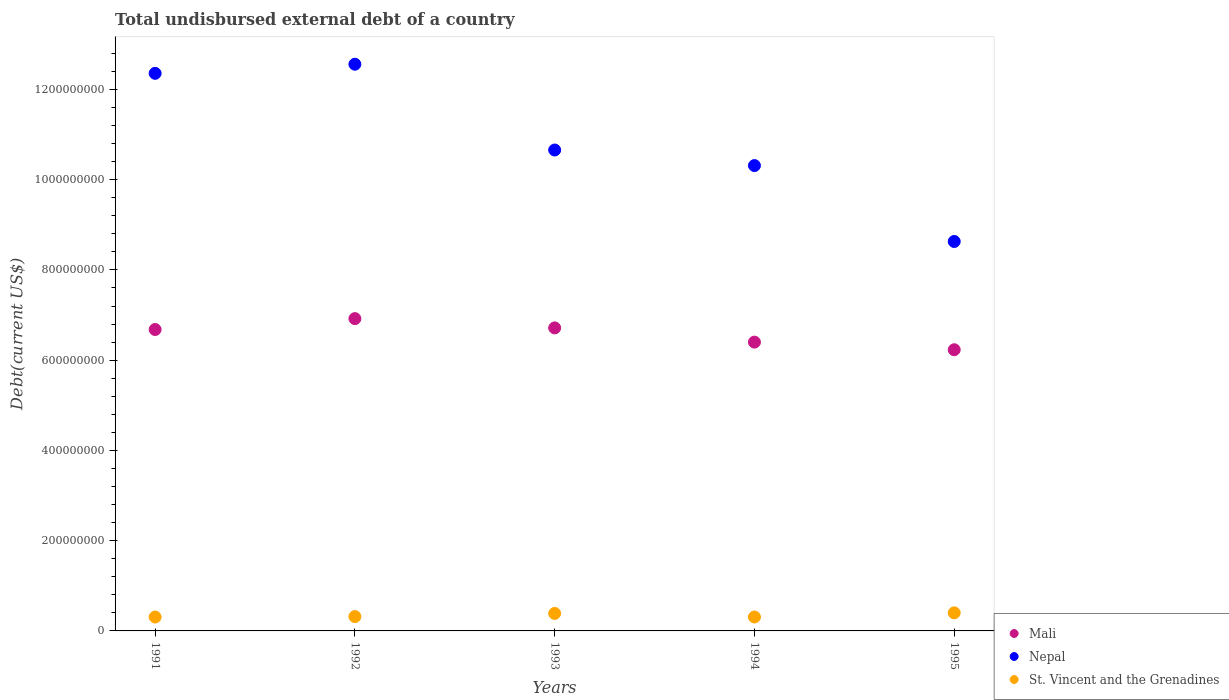What is the total undisbursed external debt in St. Vincent and the Grenadines in 1994?
Offer a terse response. 3.09e+07. Across all years, what is the maximum total undisbursed external debt in St. Vincent and the Grenadines?
Keep it short and to the point. 4.00e+07. Across all years, what is the minimum total undisbursed external debt in Nepal?
Your response must be concise. 8.63e+08. In which year was the total undisbursed external debt in Mali minimum?
Give a very brief answer. 1995. What is the total total undisbursed external debt in St. Vincent and the Grenadines in the graph?
Give a very brief answer. 1.72e+08. What is the difference between the total undisbursed external debt in St. Vincent and the Grenadines in 1992 and that in 1994?
Your answer should be compact. 9.48e+05. What is the difference between the total undisbursed external debt in St. Vincent and the Grenadines in 1993 and the total undisbursed external debt in Mali in 1994?
Make the answer very short. -6.01e+08. What is the average total undisbursed external debt in St. Vincent and the Grenadines per year?
Ensure brevity in your answer.  3.45e+07. In the year 1992, what is the difference between the total undisbursed external debt in St. Vincent and the Grenadines and total undisbursed external debt in Mali?
Offer a terse response. -6.60e+08. What is the ratio of the total undisbursed external debt in Mali in 1994 to that in 1995?
Give a very brief answer. 1.03. What is the difference between the highest and the second highest total undisbursed external debt in Nepal?
Your answer should be very brief. 2.02e+07. What is the difference between the highest and the lowest total undisbursed external debt in St. Vincent and the Grenadines?
Your response must be concise. 9.23e+06. In how many years, is the total undisbursed external debt in Nepal greater than the average total undisbursed external debt in Nepal taken over all years?
Keep it short and to the point. 2. Is the sum of the total undisbursed external debt in Mali in 1993 and 1995 greater than the maximum total undisbursed external debt in St. Vincent and the Grenadines across all years?
Your answer should be very brief. Yes. Does the total undisbursed external debt in St. Vincent and the Grenadines monotonically increase over the years?
Your answer should be very brief. No. Is the total undisbursed external debt in Mali strictly less than the total undisbursed external debt in St. Vincent and the Grenadines over the years?
Offer a terse response. No. How many dotlines are there?
Your response must be concise. 3. How many years are there in the graph?
Ensure brevity in your answer.  5. What is the difference between two consecutive major ticks on the Y-axis?
Make the answer very short. 2.00e+08. Are the values on the major ticks of Y-axis written in scientific E-notation?
Keep it short and to the point. No. Does the graph contain any zero values?
Your answer should be compact. No. Where does the legend appear in the graph?
Your answer should be compact. Bottom right. How are the legend labels stacked?
Provide a short and direct response. Vertical. What is the title of the graph?
Ensure brevity in your answer.  Total undisbursed external debt of a country. What is the label or title of the X-axis?
Give a very brief answer. Years. What is the label or title of the Y-axis?
Make the answer very short. Debt(current US$). What is the Debt(current US$) in Mali in 1991?
Make the answer very short. 6.68e+08. What is the Debt(current US$) in Nepal in 1991?
Your answer should be compact. 1.24e+09. What is the Debt(current US$) of St. Vincent and the Grenadines in 1991?
Your response must be concise. 3.08e+07. What is the Debt(current US$) of Mali in 1992?
Keep it short and to the point. 6.92e+08. What is the Debt(current US$) in Nepal in 1992?
Your answer should be very brief. 1.26e+09. What is the Debt(current US$) of St. Vincent and the Grenadines in 1992?
Your answer should be very brief. 3.18e+07. What is the Debt(current US$) in Mali in 1993?
Your response must be concise. 6.72e+08. What is the Debt(current US$) of Nepal in 1993?
Your answer should be very brief. 1.07e+09. What is the Debt(current US$) in St. Vincent and the Grenadines in 1993?
Make the answer very short. 3.88e+07. What is the Debt(current US$) of Mali in 1994?
Offer a very short reply. 6.40e+08. What is the Debt(current US$) in Nepal in 1994?
Provide a succinct answer. 1.03e+09. What is the Debt(current US$) in St. Vincent and the Grenadines in 1994?
Offer a terse response. 3.09e+07. What is the Debt(current US$) of Mali in 1995?
Your answer should be very brief. 6.23e+08. What is the Debt(current US$) in Nepal in 1995?
Keep it short and to the point. 8.63e+08. What is the Debt(current US$) of St. Vincent and the Grenadines in 1995?
Offer a very short reply. 4.00e+07. Across all years, what is the maximum Debt(current US$) in Mali?
Keep it short and to the point. 6.92e+08. Across all years, what is the maximum Debt(current US$) of Nepal?
Your response must be concise. 1.26e+09. Across all years, what is the maximum Debt(current US$) in St. Vincent and the Grenadines?
Provide a succinct answer. 4.00e+07. Across all years, what is the minimum Debt(current US$) in Mali?
Provide a short and direct response. 6.23e+08. Across all years, what is the minimum Debt(current US$) of Nepal?
Provide a short and direct response. 8.63e+08. Across all years, what is the minimum Debt(current US$) of St. Vincent and the Grenadines?
Ensure brevity in your answer.  3.08e+07. What is the total Debt(current US$) of Mali in the graph?
Keep it short and to the point. 3.29e+09. What is the total Debt(current US$) in Nepal in the graph?
Offer a terse response. 5.45e+09. What is the total Debt(current US$) of St. Vincent and the Grenadines in the graph?
Offer a very short reply. 1.72e+08. What is the difference between the Debt(current US$) in Mali in 1991 and that in 1992?
Your response must be concise. -2.41e+07. What is the difference between the Debt(current US$) in Nepal in 1991 and that in 1992?
Your answer should be very brief. -2.02e+07. What is the difference between the Debt(current US$) of St. Vincent and the Grenadines in 1991 and that in 1992?
Provide a succinct answer. -1.03e+06. What is the difference between the Debt(current US$) in Mali in 1991 and that in 1993?
Make the answer very short. -3.56e+06. What is the difference between the Debt(current US$) of Nepal in 1991 and that in 1993?
Provide a short and direct response. 1.70e+08. What is the difference between the Debt(current US$) of St. Vincent and the Grenadines in 1991 and that in 1993?
Offer a terse response. -7.96e+06. What is the difference between the Debt(current US$) in Mali in 1991 and that in 1994?
Provide a short and direct response. 2.80e+07. What is the difference between the Debt(current US$) of Nepal in 1991 and that in 1994?
Keep it short and to the point. 2.04e+08. What is the difference between the Debt(current US$) in St. Vincent and the Grenadines in 1991 and that in 1994?
Offer a terse response. -8.10e+04. What is the difference between the Debt(current US$) of Mali in 1991 and that in 1995?
Offer a terse response. 4.48e+07. What is the difference between the Debt(current US$) in Nepal in 1991 and that in 1995?
Provide a short and direct response. 3.73e+08. What is the difference between the Debt(current US$) in St. Vincent and the Grenadines in 1991 and that in 1995?
Your response must be concise. -9.23e+06. What is the difference between the Debt(current US$) of Mali in 1992 and that in 1993?
Your response must be concise. 2.06e+07. What is the difference between the Debt(current US$) in Nepal in 1992 and that in 1993?
Your answer should be very brief. 1.90e+08. What is the difference between the Debt(current US$) in St. Vincent and the Grenadines in 1992 and that in 1993?
Your answer should be very brief. -6.93e+06. What is the difference between the Debt(current US$) of Mali in 1992 and that in 1994?
Make the answer very short. 5.21e+07. What is the difference between the Debt(current US$) in Nepal in 1992 and that in 1994?
Provide a short and direct response. 2.25e+08. What is the difference between the Debt(current US$) in St. Vincent and the Grenadines in 1992 and that in 1994?
Your answer should be compact. 9.48e+05. What is the difference between the Debt(current US$) in Mali in 1992 and that in 1995?
Offer a very short reply. 6.90e+07. What is the difference between the Debt(current US$) of Nepal in 1992 and that in 1995?
Give a very brief answer. 3.93e+08. What is the difference between the Debt(current US$) in St. Vincent and the Grenadines in 1992 and that in 1995?
Provide a succinct answer. -8.20e+06. What is the difference between the Debt(current US$) in Mali in 1993 and that in 1994?
Ensure brevity in your answer.  3.15e+07. What is the difference between the Debt(current US$) in Nepal in 1993 and that in 1994?
Your response must be concise. 3.45e+07. What is the difference between the Debt(current US$) in St. Vincent and the Grenadines in 1993 and that in 1994?
Provide a succinct answer. 7.87e+06. What is the difference between the Debt(current US$) in Mali in 1993 and that in 1995?
Give a very brief answer. 4.84e+07. What is the difference between the Debt(current US$) of Nepal in 1993 and that in 1995?
Offer a terse response. 2.03e+08. What is the difference between the Debt(current US$) in St. Vincent and the Grenadines in 1993 and that in 1995?
Offer a terse response. -1.28e+06. What is the difference between the Debt(current US$) of Mali in 1994 and that in 1995?
Provide a succinct answer. 1.69e+07. What is the difference between the Debt(current US$) of Nepal in 1994 and that in 1995?
Give a very brief answer. 1.68e+08. What is the difference between the Debt(current US$) in St. Vincent and the Grenadines in 1994 and that in 1995?
Keep it short and to the point. -9.15e+06. What is the difference between the Debt(current US$) of Mali in 1991 and the Debt(current US$) of Nepal in 1992?
Give a very brief answer. -5.88e+08. What is the difference between the Debt(current US$) in Mali in 1991 and the Debt(current US$) in St. Vincent and the Grenadines in 1992?
Keep it short and to the point. 6.36e+08. What is the difference between the Debt(current US$) in Nepal in 1991 and the Debt(current US$) in St. Vincent and the Grenadines in 1992?
Give a very brief answer. 1.20e+09. What is the difference between the Debt(current US$) of Mali in 1991 and the Debt(current US$) of Nepal in 1993?
Provide a succinct answer. -3.98e+08. What is the difference between the Debt(current US$) in Mali in 1991 and the Debt(current US$) in St. Vincent and the Grenadines in 1993?
Provide a succinct answer. 6.29e+08. What is the difference between the Debt(current US$) of Nepal in 1991 and the Debt(current US$) of St. Vincent and the Grenadines in 1993?
Your response must be concise. 1.20e+09. What is the difference between the Debt(current US$) of Mali in 1991 and the Debt(current US$) of Nepal in 1994?
Your response must be concise. -3.63e+08. What is the difference between the Debt(current US$) of Mali in 1991 and the Debt(current US$) of St. Vincent and the Grenadines in 1994?
Ensure brevity in your answer.  6.37e+08. What is the difference between the Debt(current US$) of Nepal in 1991 and the Debt(current US$) of St. Vincent and the Grenadines in 1994?
Provide a short and direct response. 1.20e+09. What is the difference between the Debt(current US$) in Mali in 1991 and the Debt(current US$) in Nepal in 1995?
Provide a succinct answer. -1.95e+08. What is the difference between the Debt(current US$) in Mali in 1991 and the Debt(current US$) in St. Vincent and the Grenadines in 1995?
Provide a succinct answer. 6.28e+08. What is the difference between the Debt(current US$) of Nepal in 1991 and the Debt(current US$) of St. Vincent and the Grenadines in 1995?
Your answer should be compact. 1.20e+09. What is the difference between the Debt(current US$) in Mali in 1992 and the Debt(current US$) in Nepal in 1993?
Ensure brevity in your answer.  -3.74e+08. What is the difference between the Debt(current US$) in Mali in 1992 and the Debt(current US$) in St. Vincent and the Grenadines in 1993?
Your answer should be very brief. 6.53e+08. What is the difference between the Debt(current US$) in Nepal in 1992 and the Debt(current US$) in St. Vincent and the Grenadines in 1993?
Ensure brevity in your answer.  1.22e+09. What is the difference between the Debt(current US$) of Mali in 1992 and the Debt(current US$) of Nepal in 1994?
Your answer should be compact. -3.39e+08. What is the difference between the Debt(current US$) in Mali in 1992 and the Debt(current US$) in St. Vincent and the Grenadines in 1994?
Give a very brief answer. 6.61e+08. What is the difference between the Debt(current US$) in Nepal in 1992 and the Debt(current US$) in St. Vincent and the Grenadines in 1994?
Offer a very short reply. 1.23e+09. What is the difference between the Debt(current US$) in Mali in 1992 and the Debt(current US$) in Nepal in 1995?
Provide a short and direct response. -1.71e+08. What is the difference between the Debt(current US$) of Mali in 1992 and the Debt(current US$) of St. Vincent and the Grenadines in 1995?
Ensure brevity in your answer.  6.52e+08. What is the difference between the Debt(current US$) of Nepal in 1992 and the Debt(current US$) of St. Vincent and the Grenadines in 1995?
Provide a succinct answer. 1.22e+09. What is the difference between the Debt(current US$) in Mali in 1993 and the Debt(current US$) in Nepal in 1994?
Ensure brevity in your answer.  -3.60e+08. What is the difference between the Debt(current US$) of Mali in 1993 and the Debt(current US$) of St. Vincent and the Grenadines in 1994?
Provide a succinct answer. 6.41e+08. What is the difference between the Debt(current US$) of Nepal in 1993 and the Debt(current US$) of St. Vincent and the Grenadines in 1994?
Offer a terse response. 1.03e+09. What is the difference between the Debt(current US$) of Mali in 1993 and the Debt(current US$) of Nepal in 1995?
Give a very brief answer. -1.92e+08. What is the difference between the Debt(current US$) of Mali in 1993 and the Debt(current US$) of St. Vincent and the Grenadines in 1995?
Offer a very short reply. 6.31e+08. What is the difference between the Debt(current US$) in Nepal in 1993 and the Debt(current US$) in St. Vincent and the Grenadines in 1995?
Make the answer very short. 1.03e+09. What is the difference between the Debt(current US$) of Mali in 1994 and the Debt(current US$) of Nepal in 1995?
Ensure brevity in your answer.  -2.23e+08. What is the difference between the Debt(current US$) of Mali in 1994 and the Debt(current US$) of St. Vincent and the Grenadines in 1995?
Your answer should be compact. 6.00e+08. What is the difference between the Debt(current US$) in Nepal in 1994 and the Debt(current US$) in St. Vincent and the Grenadines in 1995?
Provide a short and direct response. 9.91e+08. What is the average Debt(current US$) of Mali per year?
Make the answer very short. 6.59e+08. What is the average Debt(current US$) of Nepal per year?
Provide a short and direct response. 1.09e+09. What is the average Debt(current US$) of St. Vincent and the Grenadines per year?
Provide a succinct answer. 3.45e+07. In the year 1991, what is the difference between the Debt(current US$) of Mali and Debt(current US$) of Nepal?
Provide a succinct answer. -5.68e+08. In the year 1991, what is the difference between the Debt(current US$) in Mali and Debt(current US$) in St. Vincent and the Grenadines?
Your answer should be very brief. 6.37e+08. In the year 1991, what is the difference between the Debt(current US$) of Nepal and Debt(current US$) of St. Vincent and the Grenadines?
Provide a short and direct response. 1.20e+09. In the year 1992, what is the difference between the Debt(current US$) in Mali and Debt(current US$) in Nepal?
Your response must be concise. -5.64e+08. In the year 1992, what is the difference between the Debt(current US$) in Mali and Debt(current US$) in St. Vincent and the Grenadines?
Your answer should be very brief. 6.60e+08. In the year 1992, what is the difference between the Debt(current US$) in Nepal and Debt(current US$) in St. Vincent and the Grenadines?
Your answer should be compact. 1.22e+09. In the year 1993, what is the difference between the Debt(current US$) in Mali and Debt(current US$) in Nepal?
Your response must be concise. -3.94e+08. In the year 1993, what is the difference between the Debt(current US$) in Mali and Debt(current US$) in St. Vincent and the Grenadines?
Provide a succinct answer. 6.33e+08. In the year 1993, what is the difference between the Debt(current US$) in Nepal and Debt(current US$) in St. Vincent and the Grenadines?
Offer a terse response. 1.03e+09. In the year 1994, what is the difference between the Debt(current US$) of Mali and Debt(current US$) of Nepal?
Provide a succinct answer. -3.91e+08. In the year 1994, what is the difference between the Debt(current US$) in Mali and Debt(current US$) in St. Vincent and the Grenadines?
Ensure brevity in your answer.  6.09e+08. In the year 1994, what is the difference between the Debt(current US$) of Nepal and Debt(current US$) of St. Vincent and the Grenadines?
Your response must be concise. 1.00e+09. In the year 1995, what is the difference between the Debt(current US$) in Mali and Debt(current US$) in Nepal?
Provide a short and direct response. -2.40e+08. In the year 1995, what is the difference between the Debt(current US$) in Mali and Debt(current US$) in St. Vincent and the Grenadines?
Your answer should be very brief. 5.83e+08. In the year 1995, what is the difference between the Debt(current US$) of Nepal and Debt(current US$) of St. Vincent and the Grenadines?
Make the answer very short. 8.23e+08. What is the ratio of the Debt(current US$) of Mali in 1991 to that in 1992?
Your answer should be compact. 0.97. What is the ratio of the Debt(current US$) in Nepal in 1991 to that in 1992?
Give a very brief answer. 0.98. What is the ratio of the Debt(current US$) in St. Vincent and the Grenadines in 1991 to that in 1992?
Provide a succinct answer. 0.97. What is the ratio of the Debt(current US$) in Nepal in 1991 to that in 1993?
Your answer should be very brief. 1.16. What is the ratio of the Debt(current US$) in St. Vincent and the Grenadines in 1991 to that in 1993?
Provide a succinct answer. 0.79. What is the ratio of the Debt(current US$) in Mali in 1991 to that in 1994?
Make the answer very short. 1.04. What is the ratio of the Debt(current US$) of Nepal in 1991 to that in 1994?
Your answer should be compact. 1.2. What is the ratio of the Debt(current US$) of Mali in 1991 to that in 1995?
Your answer should be compact. 1.07. What is the ratio of the Debt(current US$) of Nepal in 1991 to that in 1995?
Your response must be concise. 1.43. What is the ratio of the Debt(current US$) in St. Vincent and the Grenadines in 1991 to that in 1995?
Your response must be concise. 0.77. What is the ratio of the Debt(current US$) of Mali in 1992 to that in 1993?
Make the answer very short. 1.03. What is the ratio of the Debt(current US$) in Nepal in 1992 to that in 1993?
Offer a very short reply. 1.18. What is the ratio of the Debt(current US$) of St. Vincent and the Grenadines in 1992 to that in 1993?
Ensure brevity in your answer.  0.82. What is the ratio of the Debt(current US$) in Mali in 1992 to that in 1994?
Offer a very short reply. 1.08. What is the ratio of the Debt(current US$) in Nepal in 1992 to that in 1994?
Ensure brevity in your answer.  1.22. What is the ratio of the Debt(current US$) in St. Vincent and the Grenadines in 1992 to that in 1994?
Keep it short and to the point. 1.03. What is the ratio of the Debt(current US$) of Mali in 1992 to that in 1995?
Make the answer very short. 1.11. What is the ratio of the Debt(current US$) in Nepal in 1992 to that in 1995?
Provide a short and direct response. 1.46. What is the ratio of the Debt(current US$) of St. Vincent and the Grenadines in 1992 to that in 1995?
Make the answer very short. 0.8. What is the ratio of the Debt(current US$) in Mali in 1993 to that in 1994?
Provide a short and direct response. 1.05. What is the ratio of the Debt(current US$) in Nepal in 1993 to that in 1994?
Ensure brevity in your answer.  1.03. What is the ratio of the Debt(current US$) in St. Vincent and the Grenadines in 1993 to that in 1994?
Your answer should be very brief. 1.25. What is the ratio of the Debt(current US$) of Mali in 1993 to that in 1995?
Your response must be concise. 1.08. What is the ratio of the Debt(current US$) of Nepal in 1993 to that in 1995?
Provide a succinct answer. 1.23. What is the ratio of the Debt(current US$) of St. Vincent and the Grenadines in 1993 to that in 1995?
Offer a very short reply. 0.97. What is the ratio of the Debt(current US$) in Mali in 1994 to that in 1995?
Offer a terse response. 1.03. What is the ratio of the Debt(current US$) in Nepal in 1994 to that in 1995?
Provide a succinct answer. 1.19. What is the ratio of the Debt(current US$) in St. Vincent and the Grenadines in 1994 to that in 1995?
Your response must be concise. 0.77. What is the difference between the highest and the second highest Debt(current US$) in Mali?
Give a very brief answer. 2.06e+07. What is the difference between the highest and the second highest Debt(current US$) of Nepal?
Your answer should be compact. 2.02e+07. What is the difference between the highest and the second highest Debt(current US$) of St. Vincent and the Grenadines?
Your response must be concise. 1.28e+06. What is the difference between the highest and the lowest Debt(current US$) in Mali?
Ensure brevity in your answer.  6.90e+07. What is the difference between the highest and the lowest Debt(current US$) of Nepal?
Offer a very short reply. 3.93e+08. What is the difference between the highest and the lowest Debt(current US$) in St. Vincent and the Grenadines?
Provide a succinct answer. 9.23e+06. 